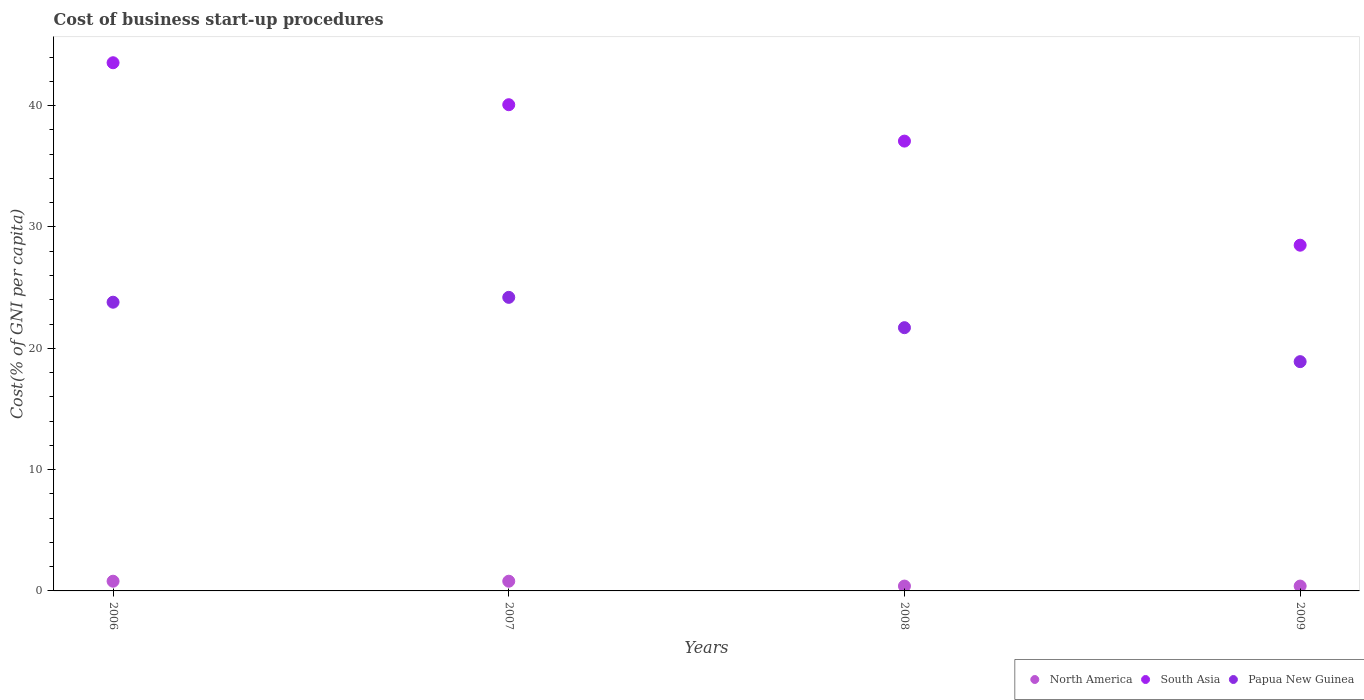Across all years, what is the maximum cost of business start-up procedures in South Asia?
Offer a very short reply. 43.54. In which year was the cost of business start-up procedures in Papua New Guinea maximum?
Your answer should be very brief. 2007. What is the total cost of business start-up procedures in South Asia in the graph?
Ensure brevity in your answer.  149.2. What is the difference between the cost of business start-up procedures in Papua New Guinea in 2007 and that in 2008?
Give a very brief answer. 2.5. What is the difference between the cost of business start-up procedures in North America in 2007 and the cost of business start-up procedures in Papua New Guinea in 2009?
Give a very brief answer. -18.1. What is the average cost of business start-up procedures in South Asia per year?
Offer a terse response. 37.3. In the year 2007, what is the difference between the cost of business start-up procedures in South Asia and cost of business start-up procedures in North America?
Ensure brevity in your answer.  39.28. In how many years, is the cost of business start-up procedures in South Asia greater than 22 %?
Give a very brief answer. 4. Is the cost of business start-up procedures in South Asia in 2008 less than that in 2009?
Your answer should be compact. No. Is the difference between the cost of business start-up procedures in South Asia in 2007 and 2008 greater than the difference between the cost of business start-up procedures in North America in 2007 and 2008?
Provide a short and direct response. Yes. In how many years, is the cost of business start-up procedures in South Asia greater than the average cost of business start-up procedures in South Asia taken over all years?
Keep it short and to the point. 2. Is the sum of the cost of business start-up procedures in North America in 2006 and 2008 greater than the maximum cost of business start-up procedures in Papua New Guinea across all years?
Your answer should be compact. No. Does the cost of business start-up procedures in North America monotonically increase over the years?
Offer a terse response. No. Is the cost of business start-up procedures in North America strictly greater than the cost of business start-up procedures in South Asia over the years?
Provide a succinct answer. No. How many dotlines are there?
Make the answer very short. 3. How many years are there in the graph?
Give a very brief answer. 4. Does the graph contain grids?
Give a very brief answer. No. Where does the legend appear in the graph?
Ensure brevity in your answer.  Bottom right. How many legend labels are there?
Give a very brief answer. 3. How are the legend labels stacked?
Provide a short and direct response. Horizontal. What is the title of the graph?
Provide a succinct answer. Cost of business start-up procedures. What is the label or title of the X-axis?
Keep it short and to the point. Years. What is the label or title of the Y-axis?
Your answer should be very brief. Cost(% of GNI per capita). What is the Cost(% of GNI per capita) in North America in 2006?
Your response must be concise. 0.8. What is the Cost(% of GNI per capita) of South Asia in 2006?
Keep it short and to the point. 43.54. What is the Cost(% of GNI per capita) of Papua New Guinea in 2006?
Your answer should be very brief. 23.8. What is the Cost(% of GNI per capita) of South Asia in 2007?
Your answer should be compact. 40.08. What is the Cost(% of GNI per capita) of Papua New Guinea in 2007?
Provide a short and direct response. 24.2. What is the Cost(% of GNI per capita) of North America in 2008?
Keep it short and to the point. 0.4. What is the Cost(% of GNI per capita) of South Asia in 2008?
Offer a terse response. 37.08. What is the Cost(% of GNI per capita) in Papua New Guinea in 2008?
Your answer should be compact. 21.7. What is the Cost(% of GNI per capita) in South Asia in 2009?
Ensure brevity in your answer.  28.5. What is the Cost(% of GNI per capita) of Papua New Guinea in 2009?
Your response must be concise. 18.9. Across all years, what is the maximum Cost(% of GNI per capita) in North America?
Your answer should be compact. 0.8. Across all years, what is the maximum Cost(% of GNI per capita) of South Asia?
Your answer should be very brief. 43.54. Across all years, what is the maximum Cost(% of GNI per capita) of Papua New Guinea?
Make the answer very short. 24.2. Across all years, what is the minimum Cost(% of GNI per capita) in South Asia?
Your response must be concise. 28.5. Across all years, what is the minimum Cost(% of GNI per capita) of Papua New Guinea?
Give a very brief answer. 18.9. What is the total Cost(% of GNI per capita) of South Asia in the graph?
Offer a very short reply. 149.2. What is the total Cost(% of GNI per capita) in Papua New Guinea in the graph?
Provide a short and direct response. 88.6. What is the difference between the Cost(% of GNI per capita) in North America in 2006 and that in 2007?
Ensure brevity in your answer.  0. What is the difference between the Cost(% of GNI per capita) of South Asia in 2006 and that in 2007?
Offer a terse response. 3.46. What is the difference between the Cost(% of GNI per capita) in Papua New Guinea in 2006 and that in 2007?
Keep it short and to the point. -0.4. What is the difference between the Cost(% of GNI per capita) in North America in 2006 and that in 2008?
Offer a very short reply. 0.4. What is the difference between the Cost(% of GNI per capita) of South Asia in 2006 and that in 2008?
Ensure brevity in your answer.  6.46. What is the difference between the Cost(% of GNI per capita) of Papua New Guinea in 2006 and that in 2008?
Provide a succinct answer. 2.1. What is the difference between the Cost(% of GNI per capita) in North America in 2006 and that in 2009?
Ensure brevity in your answer.  0.4. What is the difference between the Cost(% of GNI per capita) in South Asia in 2006 and that in 2009?
Ensure brevity in your answer.  15.04. What is the difference between the Cost(% of GNI per capita) of South Asia in 2007 and that in 2008?
Ensure brevity in your answer.  3. What is the difference between the Cost(% of GNI per capita) of South Asia in 2007 and that in 2009?
Give a very brief answer. 11.58. What is the difference between the Cost(% of GNI per capita) of Papua New Guinea in 2007 and that in 2009?
Keep it short and to the point. 5.3. What is the difference between the Cost(% of GNI per capita) in South Asia in 2008 and that in 2009?
Make the answer very short. 8.58. What is the difference between the Cost(% of GNI per capita) in North America in 2006 and the Cost(% of GNI per capita) in South Asia in 2007?
Provide a short and direct response. -39.28. What is the difference between the Cost(% of GNI per capita) in North America in 2006 and the Cost(% of GNI per capita) in Papua New Guinea in 2007?
Provide a succinct answer. -23.4. What is the difference between the Cost(% of GNI per capita) in South Asia in 2006 and the Cost(% of GNI per capita) in Papua New Guinea in 2007?
Your response must be concise. 19.34. What is the difference between the Cost(% of GNI per capita) in North America in 2006 and the Cost(% of GNI per capita) in South Asia in 2008?
Make the answer very short. -36.28. What is the difference between the Cost(% of GNI per capita) in North America in 2006 and the Cost(% of GNI per capita) in Papua New Guinea in 2008?
Provide a succinct answer. -20.9. What is the difference between the Cost(% of GNI per capita) of South Asia in 2006 and the Cost(% of GNI per capita) of Papua New Guinea in 2008?
Keep it short and to the point. 21.84. What is the difference between the Cost(% of GNI per capita) of North America in 2006 and the Cost(% of GNI per capita) of South Asia in 2009?
Provide a succinct answer. -27.7. What is the difference between the Cost(% of GNI per capita) of North America in 2006 and the Cost(% of GNI per capita) of Papua New Guinea in 2009?
Keep it short and to the point. -18.1. What is the difference between the Cost(% of GNI per capita) in South Asia in 2006 and the Cost(% of GNI per capita) in Papua New Guinea in 2009?
Provide a succinct answer. 24.64. What is the difference between the Cost(% of GNI per capita) in North America in 2007 and the Cost(% of GNI per capita) in South Asia in 2008?
Make the answer very short. -36.28. What is the difference between the Cost(% of GNI per capita) in North America in 2007 and the Cost(% of GNI per capita) in Papua New Guinea in 2008?
Ensure brevity in your answer.  -20.9. What is the difference between the Cost(% of GNI per capita) in South Asia in 2007 and the Cost(% of GNI per capita) in Papua New Guinea in 2008?
Make the answer very short. 18.38. What is the difference between the Cost(% of GNI per capita) of North America in 2007 and the Cost(% of GNI per capita) of South Asia in 2009?
Your response must be concise. -27.7. What is the difference between the Cost(% of GNI per capita) of North America in 2007 and the Cost(% of GNI per capita) of Papua New Guinea in 2009?
Your response must be concise. -18.1. What is the difference between the Cost(% of GNI per capita) of South Asia in 2007 and the Cost(% of GNI per capita) of Papua New Guinea in 2009?
Your response must be concise. 21.18. What is the difference between the Cost(% of GNI per capita) in North America in 2008 and the Cost(% of GNI per capita) in South Asia in 2009?
Provide a succinct answer. -28.1. What is the difference between the Cost(% of GNI per capita) of North America in 2008 and the Cost(% of GNI per capita) of Papua New Guinea in 2009?
Your response must be concise. -18.5. What is the difference between the Cost(% of GNI per capita) in South Asia in 2008 and the Cost(% of GNI per capita) in Papua New Guinea in 2009?
Provide a succinct answer. 18.18. What is the average Cost(% of GNI per capita) in South Asia per year?
Offer a terse response. 37.3. What is the average Cost(% of GNI per capita) of Papua New Guinea per year?
Your answer should be compact. 22.15. In the year 2006, what is the difference between the Cost(% of GNI per capita) in North America and Cost(% of GNI per capita) in South Asia?
Keep it short and to the point. -42.74. In the year 2006, what is the difference between the Cost(% of GNI per capita) of North America and Cost(% of GNI per capita) of Papua New Guinea?
Give a very brief answer. -23. In the year 2006, what is the difference between the Cost(% of GNI per capita) of South Asia and Cost(% of GNI per capita) of Papua New Guinea?
Your answer should be very brief. 19.74. In the year 2007, what is the difference between the Cost(% of GNI per capita) of North America and Cost(% of GNI per capita) of South Asia?
Offer a very short reply. -39.28. In the year 2007, what is the difference between the Cost(% of GNI per capita) in North America and Cost(% of GNI per capita) in Papua New Guinea?
Provide a short and direct response. -23.4. In the year 2007, what is the difference between the Cost(% of GNI per capita) of South Asia and Cost(% of GNI per capita) of Papua New Guinea?
Offer a very short reply. 15.88. In the year 2008, what is the difference between the Cost(% of GNI per capita) in North America and Cost(% of GNI per capita) in South Asia?
Your response must be concise. -36.68. In the year 2008, what is the difference between the Cost(% of GNI per capita) of North America and Cost(% of GNI per capita) of Papua New Guinea?
Provide a short and direct response. -21.3. In the year 2008, what is the difference between the Cost(% of GNI per capita) in South Asia and Cost(% of GNI per capita) in Papua New Guinea?
Your answer should be very brief. 15.38. In the year 2009, what is the difference between the Cost(% of GNI per capita) in North America and Cost(% of GNI per capita) in South Asia?
Provide a succinct answer. -28.1. In the year 2009, what is the difference between the Cost(% of GNI per capita) of North America and Cost(% of GNI per capita) of Papua New Guinea?
Give a very brief answer. -18.5. In the year 2009, what is the difference between the Cost(% of GNI per capita) of South Asia and Cost(% of GNI per capita) of Papua New Guinea?
Your answer should be very brief. 9.6. What is the ratio of the Cost(% of GNI per capita) in South Asia in 2006 to that in 2007?
Provide a short and direct response. 1.09. What is the ratio of the Cost(% of GNI per capita) in Papua New Guinea in 2006 to that in 2007?
Offer a terse response. 0.98. What is the ratio of the Cost(% of GNI per capita) in South Asia in 2006 to that in 2008?
Make the answer very short. 1.17. What is the ratio of the Cost(% of GNI per capita) in Papua New Guinea in 2006 to that in 2008?
Provide a succinct answer. 1.1. What is the ratio of the Cost(% of GNI per capita) in North America in 2006 to that in 2009?
Your response must be concise. 2. What is the ratio of the Cost(% of GNI per capita) of South Asia in 2006 to that in 2009?
Provide a short and direct response. 1.53. What is the ratio of the Cost(% of GNI per capita) in Papua New Guinea in 2006 to that in 2009?
Your answer should be compact. 1.26. What is the ratio of the Cost(% of GNI per capita) of North America in 2007 to that in 2008?
Give a very brief answer. 2. What is the ratio of the Cost(% of GNI per capita) of South Asia in 2007 to that in 2008?
Your answer should be very brief. 1.08. What is the ratio of the Cost(% of GNI per capita) in Papua New Guinea in 2007 to that in 2008?
Your response must be concise. 1.12. What is the ratio of the Cost(% of GNI per capita) of South Asia in 2007 to that in 2009?
Ensure brevity in your answer.  1.41. What is the ratio of the Cost(% of GNI per capita) of Papua New Guinea in 2007 to that in 2009?
Give a very brief answer. 1.28. What is the ratio of the Cost(% of GNI per capita) in South Asia in 2008 to that in 2009?
Your answer should be very brief. 1.3. What is the ratio of the Cost(% of GNI per capita) of Papua New Guinea in 2008 to that in 2009?
Offer a terse response. 1.15. What is the difference between the highest and the second highest Cost(% of GNI per capita) of South Asia?
Your answer should be very brief. 3.46. What is the difference between the highest and the second highest Cost(% of GNI per capita) of Papua New Guinea?
Keep it short and to the point. 0.4. What is the difference between the highest and the lowest Cost(% of GNI per capita) of North America?
Your response must be concise. 0.4. What is the difference between the highest and the lowest Cost(% of GNI per capita) of South Asia?
Your response must be concise. 15.04. What is the difference between the highest and the lowest Cost(% of GNI per capita) in Papua New Guinea?
Your answer should be very brief. 5.3. 